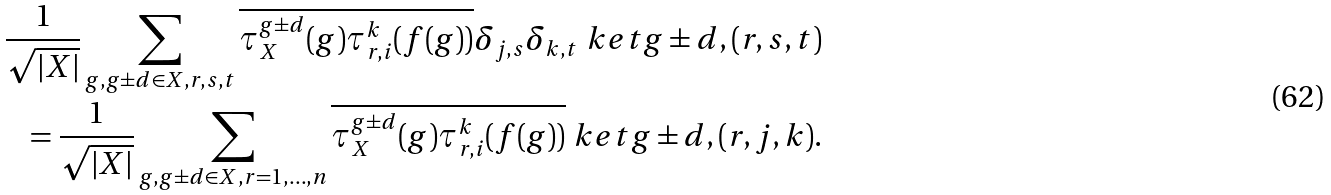Convert formula to latex. <formula><loc_0><loc_0><loc_500><loc_500>\frac { 1 } { \sqrt { | X | } } \sum _ { g , g \pm d \in X , r , s , t } \overline { \tau _ { X } ^ { g \pm d } ( g ) \tau _ { r , i } ^ { k } ( f ( g ) ) } \delta _ { j , s } \delta _ { k , t } \ k e t { g \pm d , ( r , s , t ) } \\ = \frac { 1 } { \sqrt { | X | } } \sum _ { g , g \pm d \in X , r = 1 , \dots , n } \overline { \tau _ { X } ^ { g \pm d } ( g ) \tau _ { r , i } ^ { k } ( f ( g ) ) } \ k e t { g \pm d , ( r , j , k ) } .</formula> 